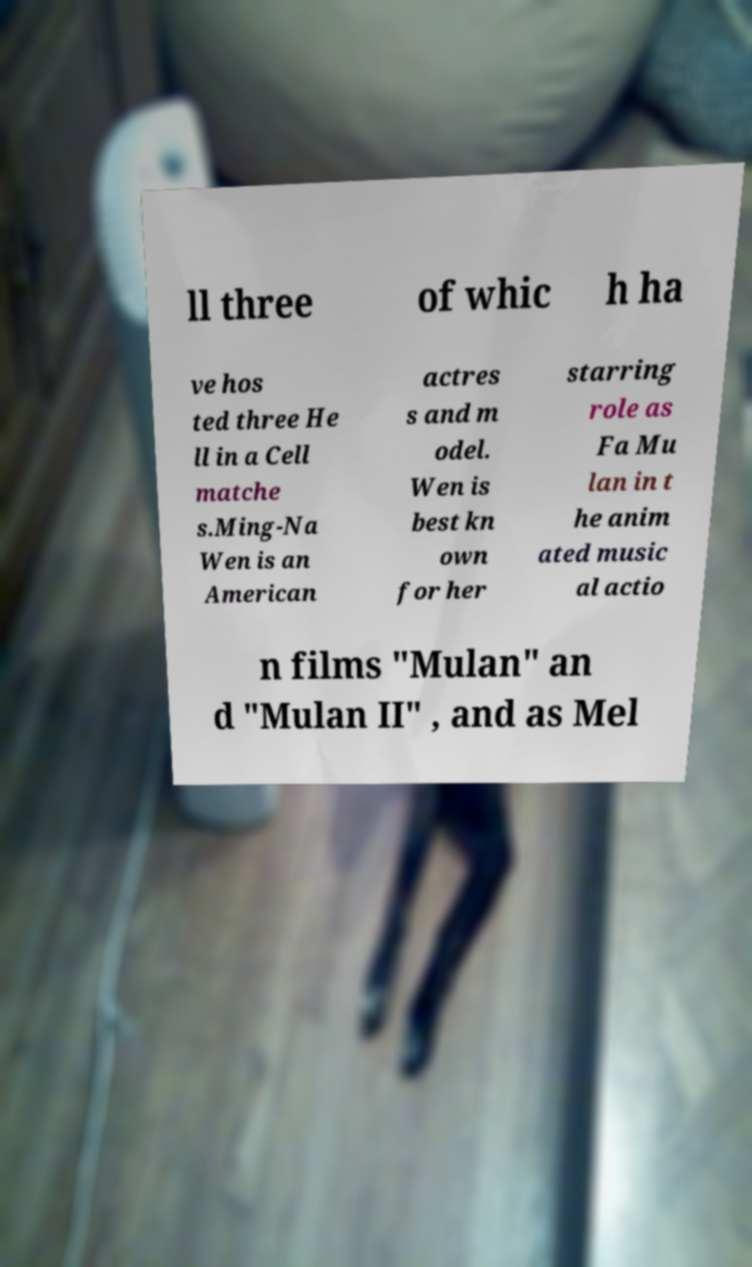Could you assist in decoding the text presented in this image and type it out clearly? ll three of whic h ha ve hos ted three He ll in a Cell matche s.Ming-Na Wen is an American actres s and m odel. Wen is best kn own for her starring role as Fa Mu lan in t he anim ated music al actio n films "Mulan" an d "Mulan II" , and as Mel 